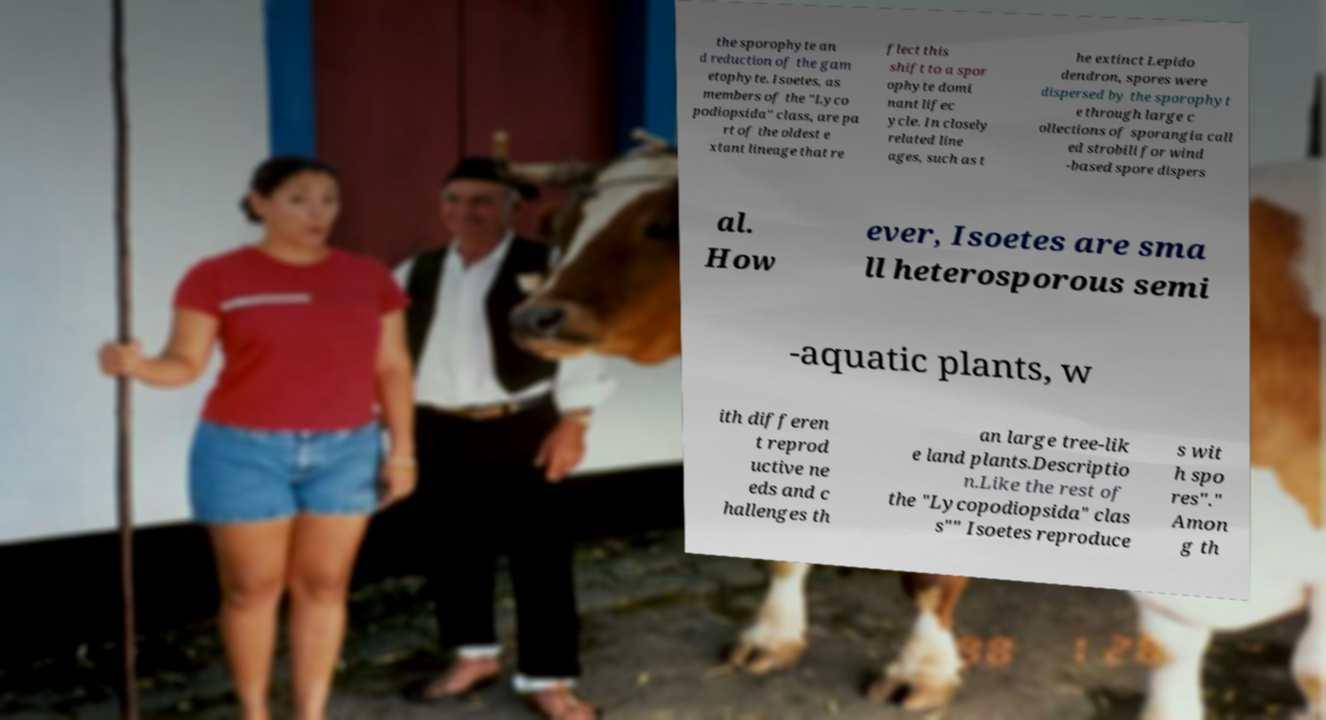I need the written content from this picture converted into text. Can you do that? the sporophyte an d reduction of the gam etophyte. Isoetes, as members of the "Lyco podiopsida" class, are pa rt of the oldest e xtant lineage that re flect this shift to a spor ophyte domi nant lifec ycle. In closely related line ages, such as t he extinct Lepido dendron, spores were dispersed by the sporophyt e through large c ollections of sporangia call ed strobili for wind -based spore dispers al. How ever, Isoetes are sma ll heterosporous semi -aquatic plants, w ith differen t reprod uctive ne eds and c hallenges th an large tree-lik e land plants.Descriptio n.Like the rest of the "Lycopodiopsida" clas s"" Isoetes reproduce s wit h spo res"." Amon g th 